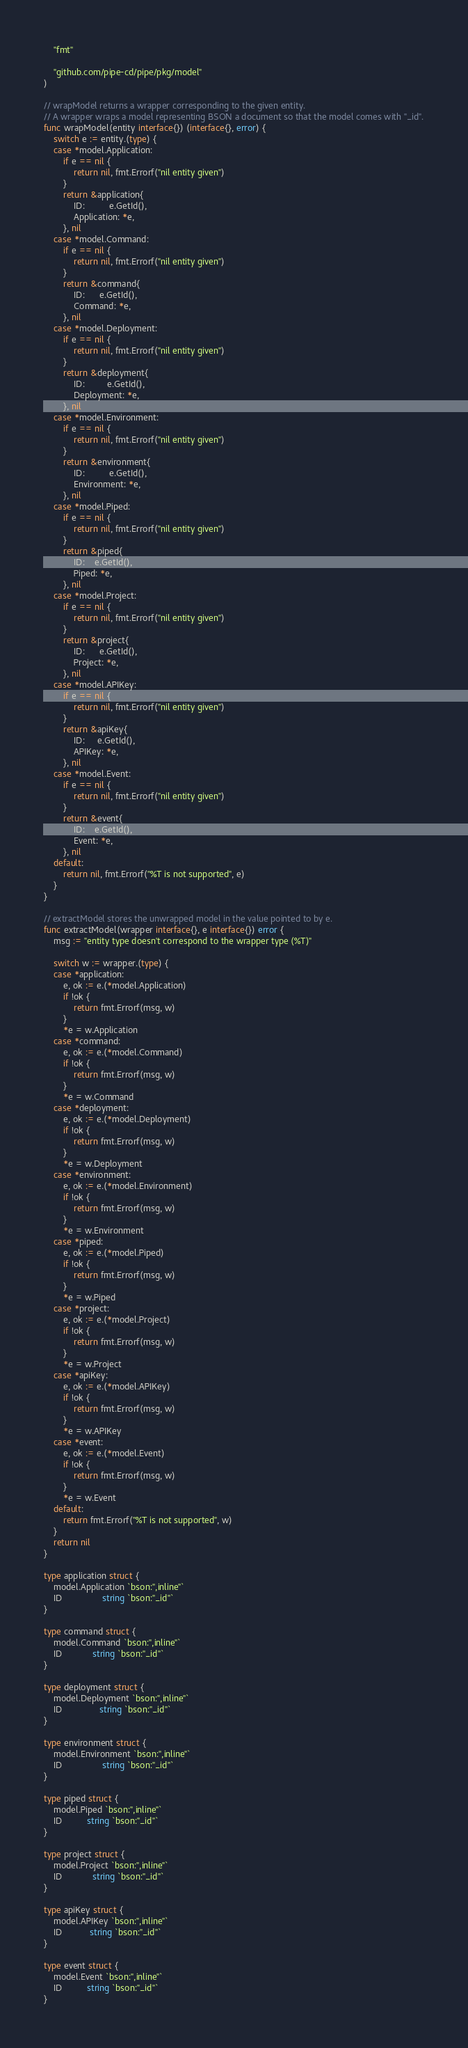<code> <loc_0><loc_0><loc_500><loc_500><_Go_>	"fmt"

	"github.com/pipe-cd/pipe/pkg/model"
)

// wrapModel returns a wrapper corresponding to the given entity.
// A wrapper wraps a model representing BSON a document so that the model comes with "_id".
func wrapModel(entity interface{}) (interface{}, error) {
	switch e := entity.(type) {
	case *model.Application:
		if e == nil {
			return nil, fmt.Errorf("nil entity given")
		}
		return &application{
			ID:          e.GetId(),
			Application: *e,
		}, nil
	case *model.Command:
		if e == nil {
			return nil, fmt.Errorf("nil entity given")
		}
		return &command{
			ID:      e.GetId(),
			Command: *e,
		}, nil
	case *model.Deployment:
		if e == nil {
			return nil, fmt.Errorf("nil entity given")
		}
		return &deployment{
			ID:         e.GetId(),
			Deployment: *e,
		}, nil
	case *model.Environment:
		if e == nil {
			return nil, fmt.Errorf("nil entity given")
		}
		return &environment{
			ID:          e.GetId(),
			Environment: *e,
		}, nil
	case *model.Piped:
		if e == nil {
			return nil, fmt.Errorf("nil entity given")
		}
		return &piped{
			ID:    e.GetId(),
			Piped: *e,
		}, nil
	case *model.Project:
		if e == nil {
			return nil, fmt.Errorf("nil entity given")
		}
		return &project{
			ID:      e.GetId(),
			Project: *e,
		}, nil
	case *model.APIKey:
		if e == nil {
			return nil, fmt.Errorf("nil entity given")
		}
		return &apiKey{
			ID:     e.GetId(),
			APIKey: *e,
		}, nil
	case *model.Event:
		if e == nil {
			return nil, fmt.Errorf("nil entity given")
		}
		return &event{
			ID:    e.GetId(),
			Event: *e,
		}, nil
	default:
		return nil, fmt.Errorf("%T is not supported", e)
	}
}

// extractModel stores the unwrapped model in the value pointed to by e.
func extractModel(wrapper interface{}, e interface{}) error {
	msg := "entity type doesn't correspond to the wrapper type (%T)"

	switch w := wrapper.(type) {
	case *application:
		e, ok := e.(*model.Application)
		if !ok {
			return fmt.Errorf(msg, w)
		}
		*e = w.Application
	case *command:
		e, ok := e.(*model.Command)
		if !ok {
			return fmt.Errorf(msg, w)
		}
		*e = w.Command
	case *deployment:
		e, ok := e.(*model.Deployment)
		if !ok {
			return fmt.Errorf(msg, w)
		}
		*e = w.Deployment
	case *environment:
		e, ok := e.(*model.Environment)
		if !ok {
			return fmt.Errorf(msg, w)
		}
		*e = w.Environment
	case *piped:
		e, ok := e.(*model.Piped)
		if !ok {
			return fmt.Errorf(msg, w)
		}
		*e = w.Piped
	case *project:
		e, ok := e.(*model.Project)
		if !ok {
			return fmt.Errorf(msg, w)
		}
		*e = w.Project
	case *apiKey:
		e, ok := e.(*model.APIKey)
		if !ok {
			return fmt.Errorf(msg, w)
		}
		*e = w.APIKey
	case *event:
		e, ok := e.(*model.Event)
		if !ok {
			return fmt.Errorf(msg, w)
		}
		*e = w.Event
	default:
		return fmt.Errorf("%T is not supported", w)
	}
	return nil
}

type application struct {
	model.Application `bson:",inline"`
	ID                string `bson:"_id"`
}

type command struct {
	model.Command `bson:",inline"`
	ID            string `bson:"_id"`
}

type deployment struct {
	model.Deployment `bson:",inline"`
	ID               string `bson:"_id"`
}

type environment struct {
	model.Environment `bson:",inline"`
	ID                string `bson:"_id"`
}

type piped struct {
	model.Piped `bson:",inline"`
	ID          string `bson:"_id"`
}

type project struct {
	model.Project `bson:",inline"`
	ID            string `bson:"_id"`
}

type apiKey struct {
	model.APIKey `bson:",inline"`
	ID           string `bson:"_id"`
}

type event struct {
	model.Event `bson:",inline"`
	ID          string `bson:"_id"`
}
</code> 